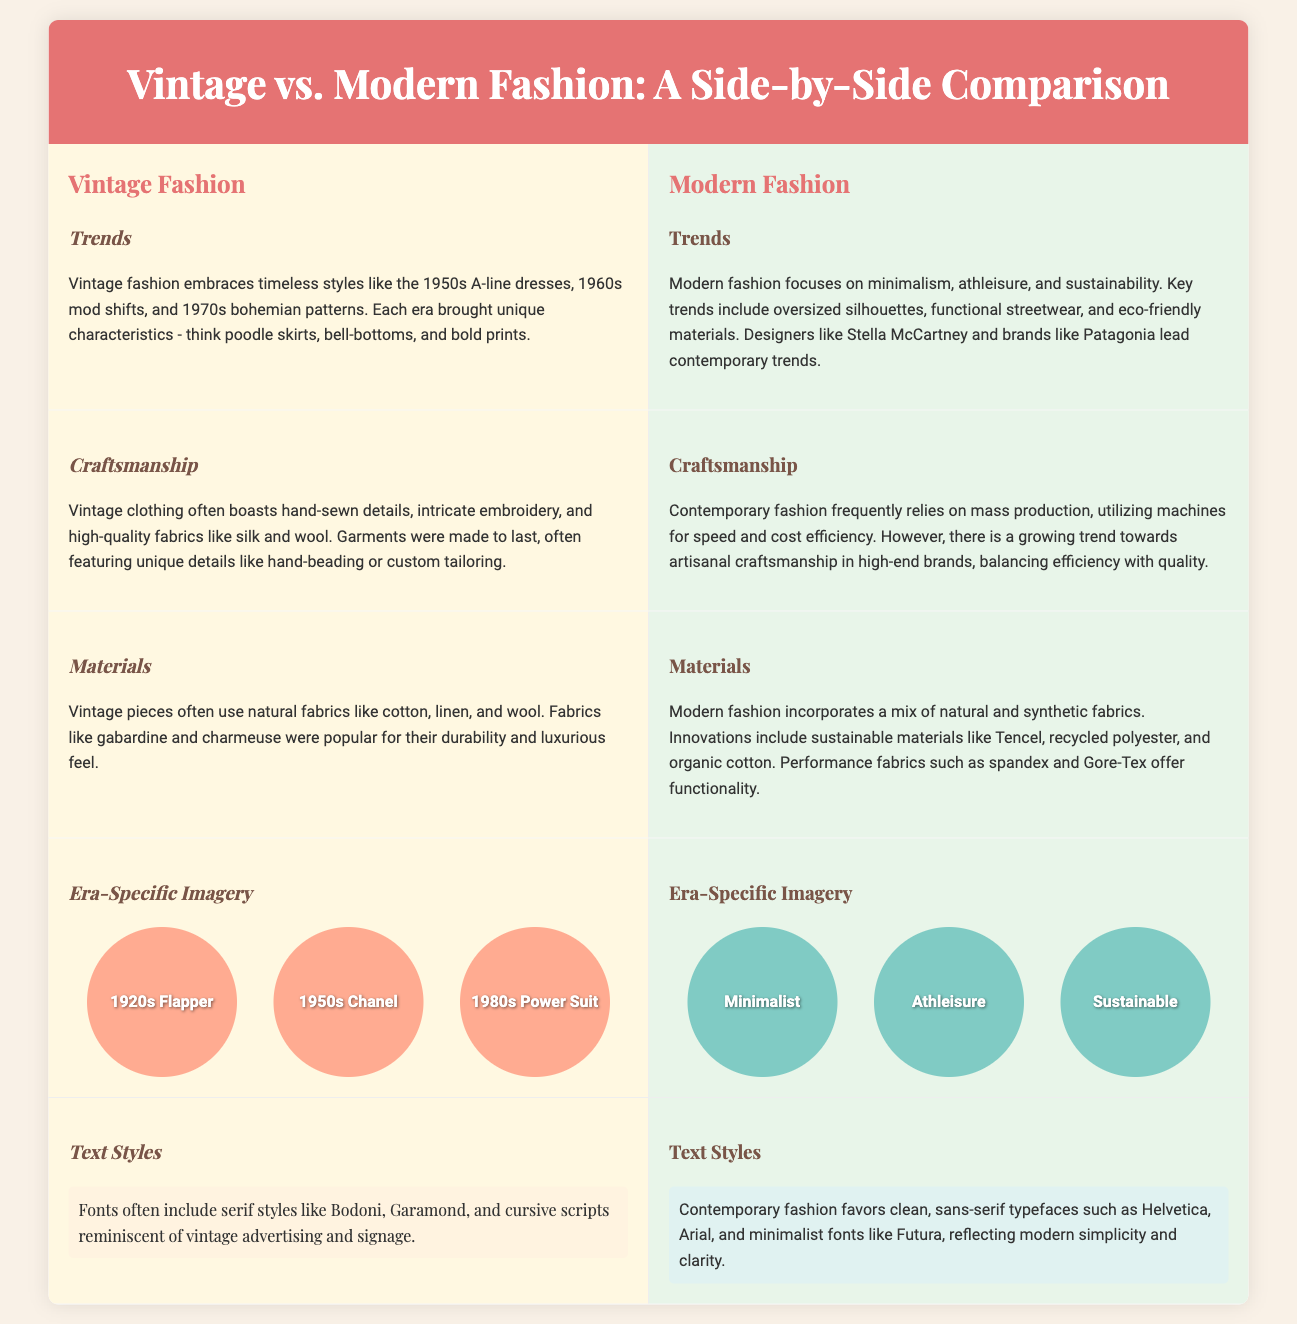what are some key trends in vintage fashion? The key trends in vintage fashion include 1950s A-line dresses, 1960s mod shifts, and 1970s bohemian patterns.
Answer: A-line dresses, mod shifts, bohemian patterns who are contemporary designers leading modern fashion trends? The contemporary designers mentioned that lead modern fashion trends include Stella McCartney and brands like Patagonia.
Answer: Stella McCartney, Patagonia what materials were popular in vintage clothing? Popular materials in vintage clothing include natural fabrics like cotton, linen, and wool, as well as gabardine and charmeuse.
Answer: Cotton, linen, wool how does modern fashion differ in craftsmanship compared to vintage fashion? Modern fashion often relies on mass production and machines, whereas vintage clothing boasts hand-sewn details and high-quality fabrics.
Answer: Mass production vs. hand-sewn details what were some era-specific images included in the vintage section? The era-specific images included in the vintage section are 1920s Flapper, 1950s Chanel, and 1980s Power Suit.
Answer: 1920s Flapper, 1950s Chanel, 1980s Power Suit which fabric is mentioned as a sustainable option in modern fashion? The fabric mentioned as a sustainable option in modern fashion is Tencel.
Answer: Tencel what do the text styles in vintage fashion emphasize? The text styles in vintage fashion emphasize serif styles like Bodoni, Garamond, and cursive scripts.
Answer: Serif styles, cursive scripts how many era-specific images are shown for modern fashion? There are three era-specific images shown for modern fashion, including Minimalist, Athleisure, and Sustainable.
Answer: Three what is a significant feature of vintage craftsmanship? A significant feature of vintage craftsmanship is intricate embroidery.
Answer: Intricate embroidery what types of fabrics are commonly used in modern fashion? Modern fashion commonly uses a mix of natural and synthetic fabrics, including sustainable materials.
Answer: Natural and synthetic fabrics 